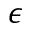<formula> <loc_0><loc_0><loc_500><loc_500>\epsilon</formula> 